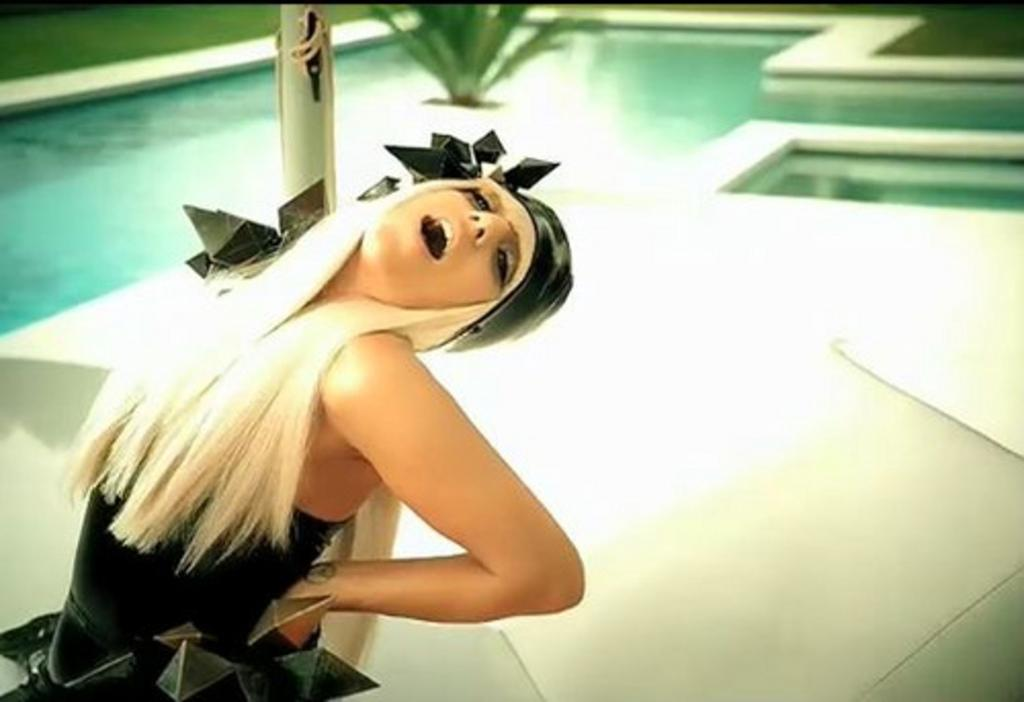What is the girl doing in the image? The girl is lying on a pole in the image. What can be seen in the background of the image? There is a swimming pool in the background of the image. What is the condition of the water in the swimming pool? The swimming pool contains water. What is located beside the swimming pool? There is a flower pot beside the swimming pool. What type of chair is placed at the end of the scene? There is no chair present in the image, and the term "scene" is not applicable to the given facts. 